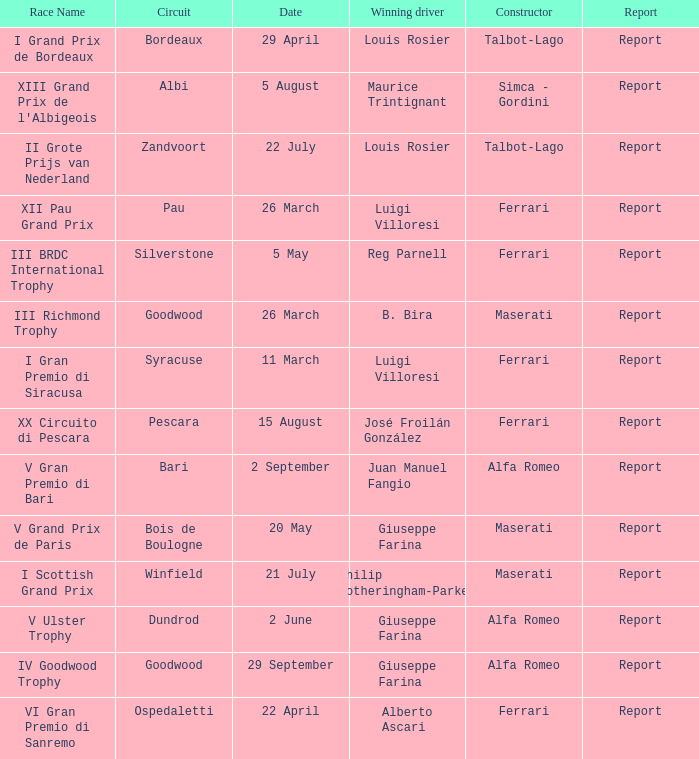Name the report on 20 may Report. 